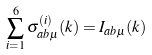<formula> <loc_0><loc_0><loc_500><loc_500>\sum _ { i = 1 } ^ { 6 } \sigma _ { a b \mu } ^ { ( i ) } ( k ) = I _ { a b \mu } ( k )</formula> 